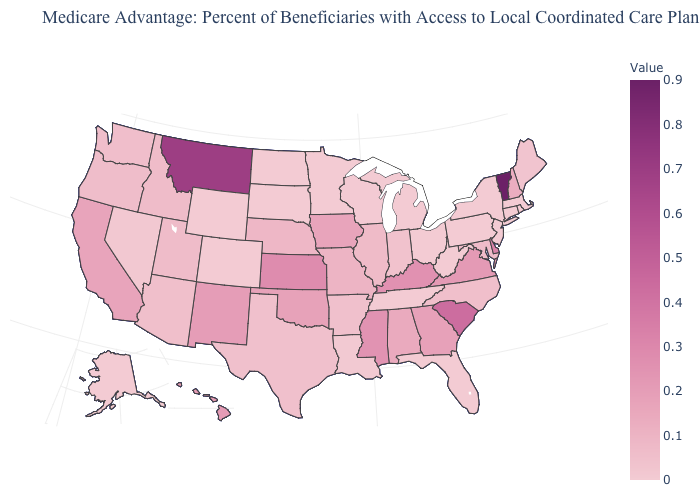Which states have the lowest value in the West?
Answer briefly. Colorado, Alaska, Wyoming. Among the states that border North Dakota , does Montana have the highest value?
Answer briefly. Yes. Is the legend a continuous bar?
Short answer required. Yes. Among the states that border Arkansas , does Missouri have the highest value?
Short answer required. No. Does the map have missing data?
Give a very brief answer. No. Which states have the highest value in the USA?
Quick response, please. Vermont. Among the states that border Utah , does Colorado have the lowest value?
Be succinct. Yes. 